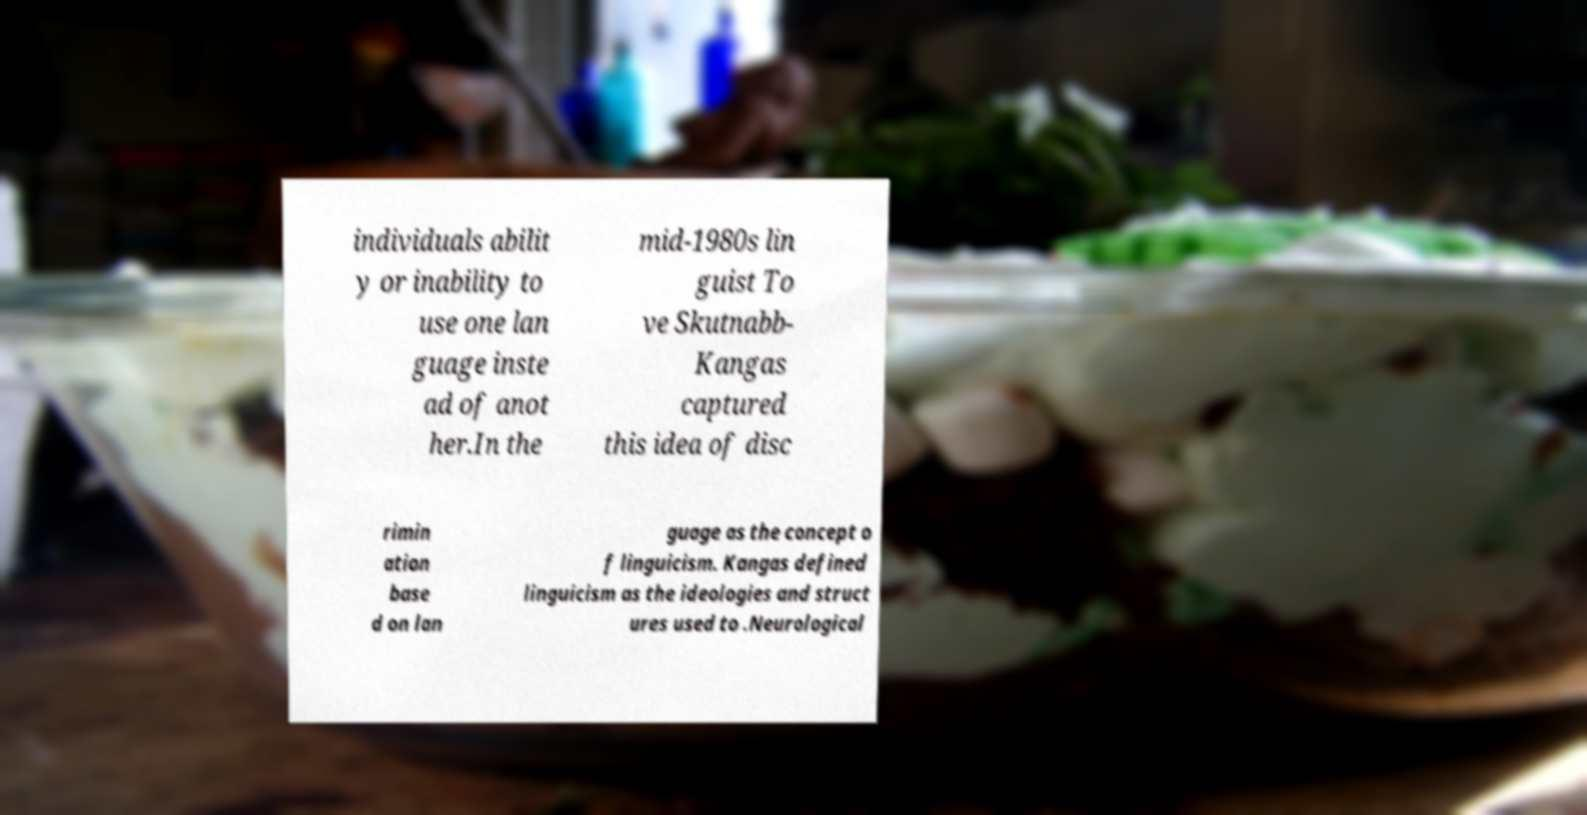For documentation purposes, I need the text within this image transcribed. Could you provide that? individuals abilit y or inability to use one lan guage inste ad of anot her.In the mid-1980s lin guist To ve Skutnabb- Kangas captured this idea of disc rimin ation base d on lan guage as the concept o f linguicism. Kangas defined linguicism as the ideologies and struct ures used to .Neurological 